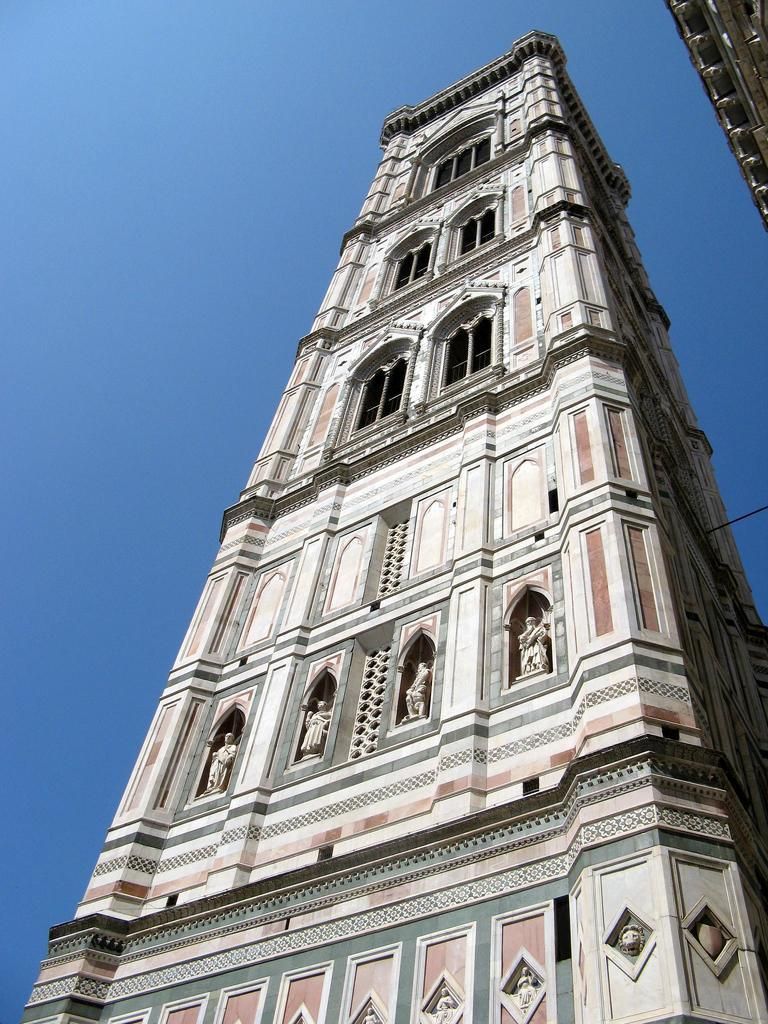What is the main structure in the image? There is a tower in the image. What can be seen on the tower? There are statues on the tower. Can you describe the object in the top right of the image? Unfortunately, the facts provided do not give enough information to describe the object in the top right of the image. What type of hat is the character wearing in the image? There is no character or hat present in the image; it features a tower with statues. 